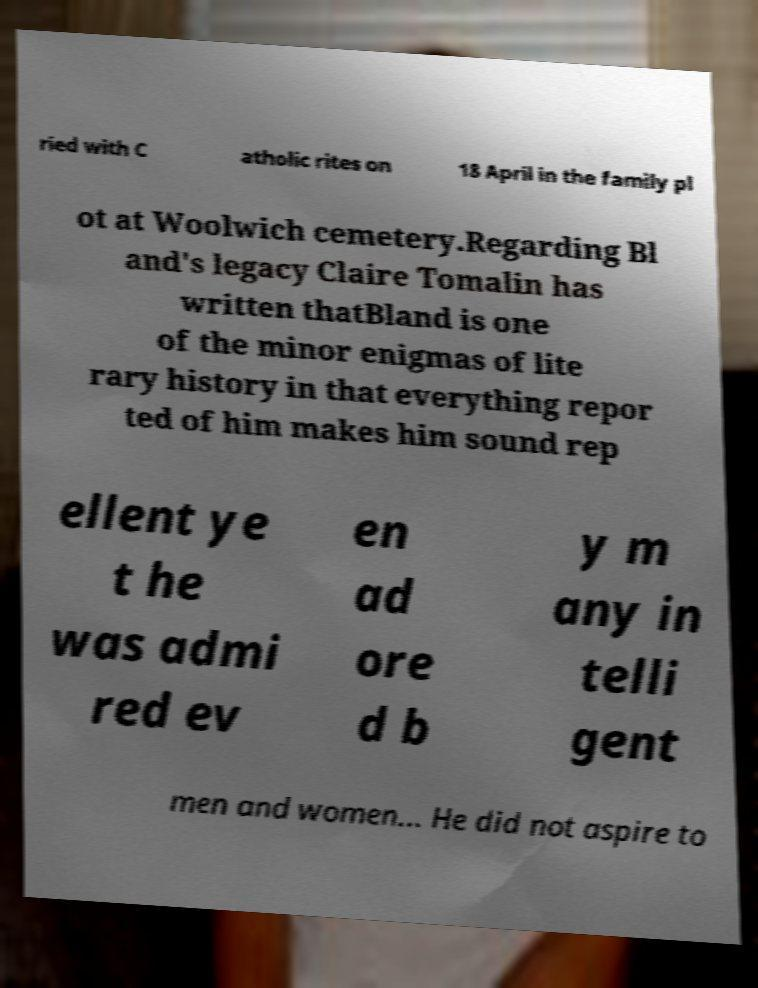Please read and relay the text visible in this image. What does it say? ried with C atholic rites on 18 April in the family pl ot at Woolwich cemetery.Regarding Bl and's legacy Claire Tomalin has written thatBland is one of the minor enigmas of lite rary history in that everything repor ted of him makes him sound rep ellent ye t he was admi red ev en ad ore d b y m any in telli gent men and women... He did not aspire to 